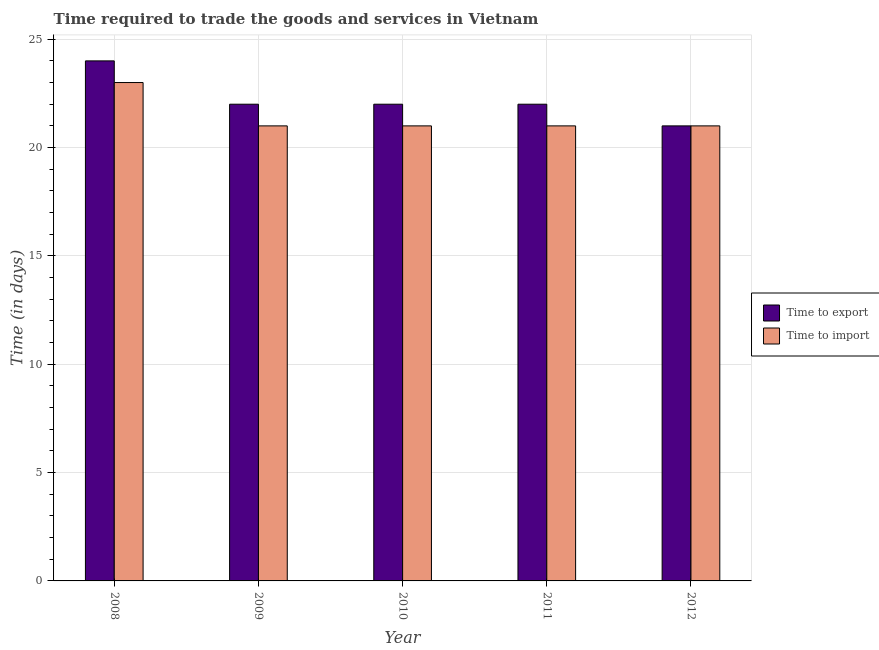Are the number of bars per tick equal to the number of legend labels?
Your answer should be compact. Yes. Are the number of bars on each tick of the X-axis equal?
Provide a short and direct response. Yes. How many bars are there on the 4th tick from the left?
Offer a terse response. 2. How many bars are there on the 5th tick from the right?
Make the answer very short. 2. What is the label of the 5th group of bars from the left?
Your response must be concise. 2012. What is the time to import in 2009?
Offer a terse response. 21. Across all years, what is the maximum time to import?
Keep it short and to the point. 23. Across all years, what is the minimum time to import?
Offer a terse response. 21. What is the total time to import in the graph?
Give a very brief answer. 107. What is the difference between the time to import in 2009 and that in 2011?
Ensure brevity in your answer.  0. What is the difference between the time to import in 2011 and the time to export in 2008?
Offer a terse response. -2. What is the ratio of the time to import in 2008 to that in 2012?
Ensure brevity in your answer.  1.1. Is the time to import in 2008 less than that in 2009?
Make the answer very short. No. What is the difference between the highest and the lowest time to export?
Provide a succinct answer. 3. Is the sum of the time to export in 2008 and 2011 greater than the maximum time to import across all years?
Keep it short and to the point. Yes. What does the 1st bar from the left in 2009 represents?
Give a very brief answer. Time to export. What does the 2nd bar from the right in 2011 represents?
Provide a succinct answer. Time to export. How many bars are there?
Keep it short and to the point. 10. What is the difference between two consecutive major ticks on the Y-axis?
Provide a succinct answer. 5. Does the graph contain grids?
Offer a very short reply. Yes. Where does the legend appear in the graph?
Give a very brief answer. Center right. What is the title of the graph?
Your answer should be compact. Time required to trade the goods and services in Vietnam. What is the label or title of the Y-axis?
Provide a succinct answer. Time (in days). What is the Time (in days) of Time to export in 2008?
Make the answer very short. 24. What is the Time (in days) in Time to import in 2008?
Provide a succinct answer. 23. What is the Time (in days) of Time to export in 2009?
Your answer should be compact. 22. What is the Time (in days) of Time to export in 2010?
Offer a very short reply. 22. What is the Time (in days) of Time to import in 2010?
Give a very brief answer. 21. Across all years, what is the maximum Time (in days) of Time to export?
Offer a terse response. 24. What is the total Time (in days) in Time to export in the graph?
Make the answer very short. 111. What is the total Time (in days) of Time to import in the graph?
Make the answer very short. 107. What is the difference between the Time (in days) of Time to import in 2008 and that in 2009?
Your answer should be very brief. 2. What is the difference between the Time (in days) of Time to export in 2008 and that in 2010?
Provide a succinct answer. 2. What is the difference between the Time (in days) of Time to import in 2008 and that in 2010?
Give a very brief answer. 2. What is the difference between the Time (in days) of Time to export in 2008 and that in 2011?
Keep it short and to the point. 2. What is the difference between the Time (in days) of Time to import in 2008 and that in 2011?
Provide a succinct answer. 2. What is the difference between the Time (in days) in Time to export in 2008 and that in 2012?
Offer a terse response. 3. What is the difference between the Time (in days) of Time to import in 2008 and that in 2012?
Provide a short and direct response. 2. What is the difference between the Time (in days) of Time to import in 2009 and that in 2011?
Keep it short and to the point. 0. What is the difference between the Time (in days) of Time to export in 2009 and that in 2012?
Give a very brief answer. 1. What is the difference between the Time (in days) in Time to export in 2010 and that in 2011?
Provide a short and direct response. 0. What is the difference between the Time (in days) of Time to export in 2010 and that in 2012?
Offer a terse response. 1. What is the difference between the Time (in days) of Time to import in 2011 and that in 2012?
Your answer should be very brief. 0. What is the difference between the Time (in days) in Time to export in 2008 and the Time (in days) in Time to import in 2010?
Offer a very short reply. 3. What is the difference between the Time (in days) of Time to export in 2008 and the Time (in days) of Time to import in 2011?
Keep it short and to the point. 3. What is the difference between the Time (in days) of Time to export in 2008 and the Time (in days) of Time to import in 2012?
Your response must be concise. 3. What is the difference between the Time (in days) in Time to export in 2009 and the Time (in days) in Time to import in 2011?
Your response must be concise. 1. What is the difference between the Time (in days) of Time to export in 2009 and the Time (in days) of Time to import in 2012?
Keep it short and to the point. 1. What is the difference between the Time (in days) in Time to export in 2010 and the Time (in days) in Time to import in 2011?
Your response must be concise. 1. What is the average Time (in days) in Time to export per year?
Ensure brevity in your answer.  22.2. What is the average Time (in days) in Time to import per year?
Offer a terse response. 21.4. In the year 2008, what is the difference between the Time (in days) in Time to export and Time (in days) in Time to import?
Provide a short and direct response. 1. In the year 2009, what is the difference between the Time (in days) of Time to export and Time (in days) of Time to import?
Keep it short and to the point. 1. In the year 2010, what is the difference between the Time (in days) of Time to export and Time (in days) of Time to import?
Make the answer very short. 1. What is the ratio of the Time (in days) of Time to export in 2008 to that in 2009?
Your answer should be compact. 1.09. What is the ratio of the Time (in days) of Time to import in 2008 to that in 2009?
Your answer should be very brief. 1.1. What is the ratio of the Time (in days) of Time to import in 2008 to that in 2010?
Your response must be concise. 1.1. What is the ratio of the Time (in days) of Time to export in 2008 to that in 2011?
Offer a very short reply. 1.09. What is the ratio of the Time (in days) in Time to import in 2008 to that in 2011?
Provide a short and direct response. 1.1. What is the ratio of the Time (in days) in Time to export in 2008 to that in 2012?
Your response must be concise. 1.14. What is the ratio of the Time (in days) in Time to import in 2008 to that in 2012?
Give a very brief answer. 1.1. What is the ratio of the Time (in days) of Time to export in 2009 to that in 2010?
Your response must be concise. 1. What is the ratio of the Time (in days) in Time to import in 2009 to that in 2011?
Ensure brevity in your answer.  1. What is the ratio of the Time (in days) of Time to export in 2009 to that in 2012?
Give a very brief answer. 1.05. What is the ratio of the Time (in days) of Time to export in 2010 to that in 2011?
Offer a terse response. 1. What is the ratio of the Time (in days) of Time to export in 2010 to that in 2012?
Provide a succinct answer. 1.05. What is the ratio of the Time (in days) in Time to import in 2010 to that in 2012?
Make the answer very short. 1. What is the ratio of the Time (in days) in Time to export in 2011 to that in 2012?
Offer a very short reply. 1.05. What is the ratio of the Time (in days) in Time to import in 2011 to that in 2012?
Your answer should be compact. 1. What is the difference between the highest and the lowest Time (in days) of Time to import?
Provide a succinct answer. 2. 